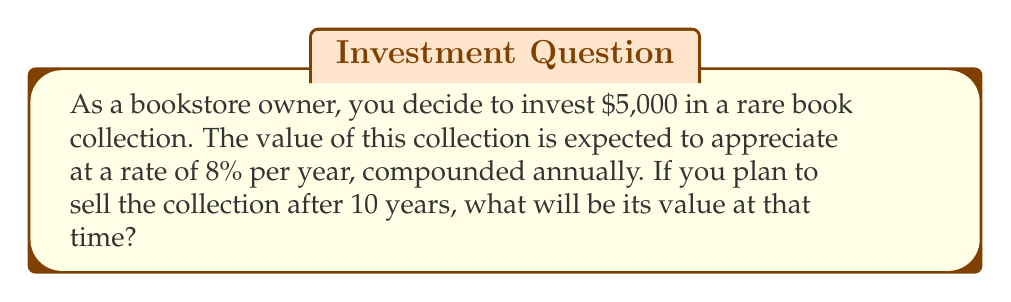Help me with this question. To solve this problem, we'll use the compound interest formula:

$$ A = P(1 + r)^n $$

Where:
$A$ = Final amount
$P$ = Principal (initial investment)
$r$ = Annual interest rate (as a decimal)
$n$ = Number of years

Given:
$P = \$5,000$
$r = 8\% = 0.08$
$n = 10$ years

Let's substitute these values into the formula:

$$ A = 5000(1 + 0.08)^{10} $$

Now, let's calculate step by step:

1) First, calculate $(1 + 0.08)$:
   $1 + 0.08 = 1.08$

2) Now, raise 1.08 to the power of 10:
   $1.08^{10} \approx 2.1589$

3) Finally, multiply this by the initial investment:
   $5000 \times 2.1589 \approx 10,794.50$

Therefore, after 10 years, the rare book collection will be worth approximately $10,794.50.
Answer: $10,794.50 